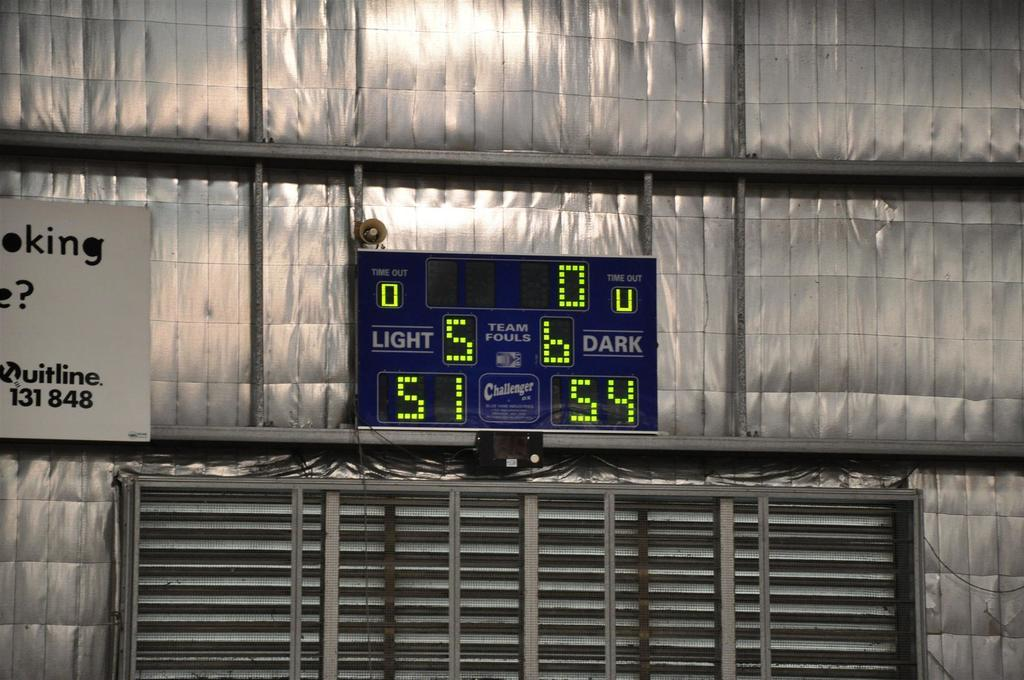<image>
Describe the image concisely. the number 5 is on the scoreboard in green 